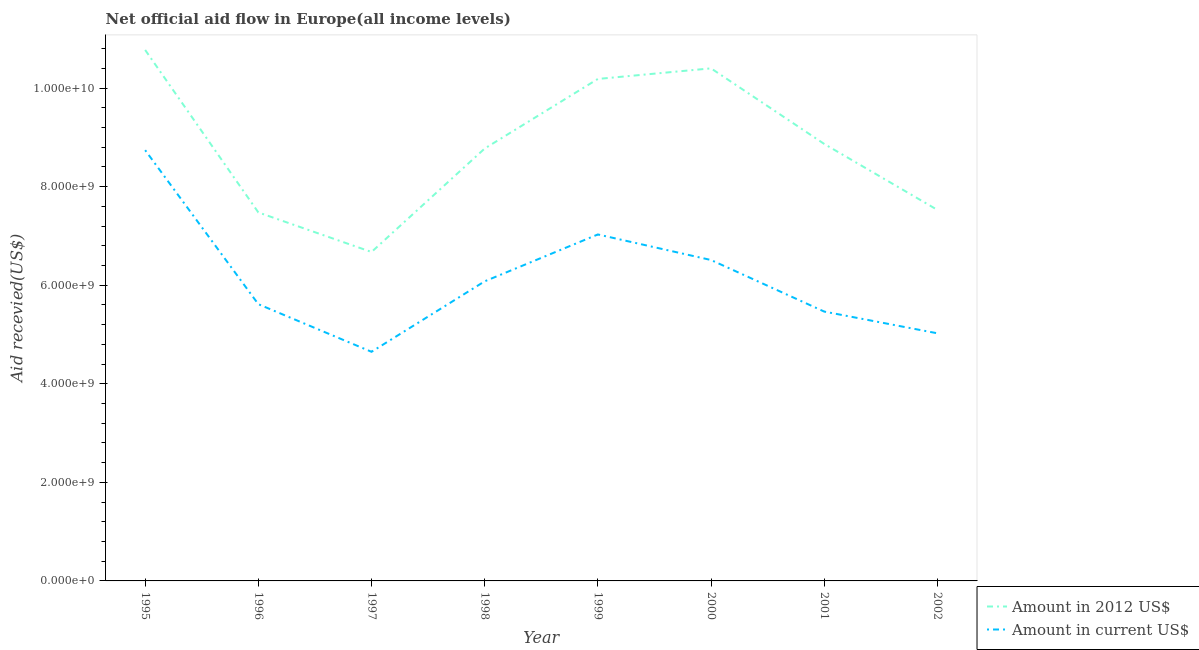How many different coloured lines are there?
Offer a very short reply. 2. Does the line corresponding to amount of aid received(expressed in 2012 us$) intersect with the line corresponding to amount of aid received(expressed in us$)?
Provide a succinct answer. No. Is the number of lines equal to the number of legend labels?
Keep it short and to the point. Yes. What is the amount of aid received(expressed in us$) in 1998?
Your answer should be compact. 6.08e+09. Across all years, what is the maximum amount of aid received(expressed in 2012 us$)?
Ensure brevity in your answer.  1.08e+1. Across all years, what is the minimum amount of aid received(expressed in us$)?
Your answer should be compact. 4.65e+09. In which year was the amount of aid received(expressed in 2012 us$) maximum?
Your answer should be compact. 1995. In which year was the amount of aid received(expressed in 2012 us$) minimum?
Your answer should be compact. 1997. What is the total amount of aid received(expressed in us$) in the graph?
Offer a very short reply. 4.91e+1. What is the difference between the amount of aid received(expressed in 2012 us$) in 1996 and that in 2000?
Provide a short and direct response. -2.92e+09. What is the difference between the amount of aid received(expressed in 2012 us$) in 1999 and the amount of aid received(expressed in us$) in 1995?
Your answer should be compact. 1.45e+09. What is the average amount of aid received(expressed in 2012 us$) per year?
Give a very brief answer. 8.84e+09. In the year 2001, what is the difference between the amount of aid received(expressed in 2012 us$) and amount of aid received(expressed in us$)?
Ensure brevity in your answer.  3.40e+09. What is the ratio of the amount of aid received(expressed in 2012 us$) in 1999 to that in 2000?
Your answer should be very brief. 0.98. Is the amount of aid received(expressed in us$) in 1997 less than that in 1999?
Ensure brevity in your answer.  Yes. What is the difference between the highest and the second highest amount of aid received(expressed in 2012 us$)?
Give a very brief answer. 3.73e+08. What is the difference between the highest and the lowest amount of aid received(expressed in 2012 us$)?
Give a very brief answer. 4.10e+09. In how many years, is the amount of aid received(expressed in 2012 us$) greater than the average amount of aid received(expressed in 2012 us$) taken over all years?
Make the answer very short. 4. Is the sum of the amount of aid received(expressed in 2012 us$) in 1995 and 2002 greater than the maximum amount of aid received(expressed in us$) across all years?
Your response must be concise. Yes. Are the values on the major ticks of Y-axis written in scientific E-notation?
Your answer should be compact. Yes. How many legend labels are there?
Your answer should be compact. 2. What is the title of the graph?
Give a very brief answer. Net official aid flow in Europe(all income levels). What is the label or title of the Y-axis?
Ensure brevity in your answer.  Aid recevied(US$). What is the Aid recevied(US$) in Amount in 2012 US$ in 1995?
Offer a very short reply. 1.08e+1. What is the Aid recevied(US$) in Amount in current US$ in 1995?
Ensure brevity in your answer.  8.74e+09. What is the Aid recevied(US$) in Amount in 2012 US$ in 1996?
Offer a terse response. 7.48e+09. What is the Aid recevied(US$) of Amount in current US$ in 1996?
Give a very brief answer. 5.62e+09. What is the Aid recevied(US$) in Amount in 2012 US$ in 1997?
Provide a succinct answer. 6.67e+09. What is the Aid recevied(US$) of Amount in current US$ in 1997?
Ensure brevity in your answer.  4.65e+09. What is the Aid recevied(US$) in Amount in 2012 US$ in 1998?
Provide a succinct answer. 8.77e+09. What is the Aid recevied(US$) of Amount in current US$ in 1998?
Keep it short and to the point. 6.08e+09. What is the Aid recevied(US$) of Amount in 2012 US$ in 1999?
Provide a short and direct response. 1.02e+1. What is the Aid recevied(US$) in Amount in current US$ in 1999?
Give a very brief answer. 7.03e+09. What is the Aid recevied(US$) in Amount in 2012 US$ in 2000?
Give a very brief answer. 1.04e+1. What is the Aid recevied(US$) of Amount in current US$ in 2000?
Offer a very short reply. 6.51e+09. What is the Aid recevied(US$) in Amount in 2012 US$ in 2001?
Make the answer very short. 8.87e+09. What is the Aid recevied(US$) of Amount in current US$ in 2001?
Give a very brief answer. 5.47e+09. What is the Aid recevied(US$) of Amount in 2012 US$ in 2002?
Ensure brevity in your answer.  7.53e+09. What is the Aid recevied(US$) of Amount in current US$ in 2002?
Your answer should be compact. 5.02e+09. Across all years, what is the maximum Aid recevied(US$) of Amount in 2012 US$?
Provide a short and direct response. 1.08e+1. Across all years, what is the maximum Aid recevied(US$) in Amount in current US$?
Your answer should be compact. 8.74e+09. Across all years, what is the minimum Aid recevied(US$) of Amount in 2012 US$?
Offer a very short reply. 6.67e+09. Across all years, what is the minimum Aid recevied(US$) of Amount in current US$?
Keep it short and to the point. 4.65e+09. What is the total Aid recevied(US$) of Amount in 2012 US$ in the graph?
Provide a short and direct response. 7.07e+1. What is the total Aid recevied(US$) of Amount in current US$ in the graph?
Give a very brief answer. 4.91e+1. What is the difference between the Aid recevied(US$) of Amount in 2012 US$ in 1995 and that in 1996?
Your answer should be compact. 3.30e+09. What is the difference between the Aid recevied(US$) in Amount in current US$ in 1995 and that in 1996?
Give a very brief answer. 3.13e+09. What is the difference between the Aid recevied(US$) in Amount in 2012 US$ in 1995 and that in 1997?
Offer a very short reply. 4.10e+09. What is the difference between the Aid recevied(US$) in Amount in current US$ in 1995 and that in 1997?
Provide a succinct answer. 4.09e+09. What is the difference between the Aid recevied(US$) in Amount in 2012 US$ in 1995 and that in 1998?
Your answer should be very brief. 2.00e+09. What is the difference between the Aid recevied(US$) of Amount in current US$ in 1995 and that in 1998?
Offer a terse response. 2.66e+09. What is the difference between the Aid recevied(US$) of Amount in 2012 US$ in 1995 and that in 1999?
Offer a terse response. 5.88e+08. What is the difference between the Aid recevied(US$) of Amount in current US$ in 1995 and that in 1999?
Provide a short and direct response. 1.71e+09. What is the difference between the Aid recevied(US$) in Amount in 2012 US$ in 1995 and that in 2000?
Your answer should be very brief. 3.73e+08. What is the difference between the Aid recevied(US$) in Amount in current US$ in 1995 and that in 2000?
Make the answer very short. 2.23e+09. What is the difference between the Aid recevied(US$) in Amount in 2012 US$ in 1995 and that in 2001?
Give a very brief answer. 1.91e+09. What is the difference between the Aid recevied(US$) in Amount in current US$ in 1995 and that in 2001?
Your response must be concise. 3.28e+09. What is the difference between the Aid recevied(US$) in Amount in 2012 US$ in 1995 and that in 2002?
Provide a succinct answer. 3.25e+09. What is the difference between the Aid recevied(US$) of Amount in current US$ in 1995 and that in 2002?
Provide a short and direct response. 3.72e+09. What is the difference between the Aid recevied(US$) of Amount in 2012 US$ in 1996 and that in 1997?
Provide a short and direct response. 8.03e+08. What is the difference between the Aid recevied(US$) in Amount in current US$ in 1996 and that in 1997?
Give a very brief answer. 9.66e+08. What is the difference between the Aid recevied(US$) of Amount in 2012 US$ in 1996 and that in 1998?
Provide a short and direct response. -1.30e+09. What is the difference between the Aid recevied(US$) of Amount in current US$ in 1996 and that in 1998?
Provide a succinct answer. -4.64e+08. What is the difference between the Aid recevied(US$) of Amount in 2012 US$ in 1996 and that in 1999?
Provide a succinct answer. -2.71e+09. What is the difference between the Aid recevied(US$) in Amount in current US$ in 1996 and that in 1999?
Your answer should be very brief. -1.41e+09. What is the difference between the Aid recevied(US$) of Amount in 2012 US$ in 1996 and that in 2000?
Give a very brief answer. -2.92e+09. What is the difference between the Aid recevied(US$) of Amount in current US$ in 1996 and that in 2000?
Offer a terse response. -8.96e+08. What is the difference between the Aid recevied(US$) in Amount in 2012 US$ in 1996 and that in 2001?
Your response must be concise. -1.39e+09. What is the difference between the Aid recevied(US$) in Amount in current US$ in 1996 and that in 2001?
Give a very brief answer. 1.50e+08. What is the difference between the Aid recevied(US$) in Amount in 2012 US$ in 1996 and that in 2002?
Your response must be concise. -5.12e+07. What is the difference between the Aid recevied(US$) of Amount in current US$ in 1996 and that in 2002?
Provide a short and direct response. 5.91e+08. What is the difference between the Aid recevied(US$) in Amount in 2012 US$ in 1997 and that in 1998?
Offer a very short reply. -2.10e+09. What is the difference between the Aid recevied(US$) of Amount in current US$ in 1997 and that in 1998?
Your answer should be compact. -1.43e+09. What is the difference between the Aid recevied(US$) in Amount in 2012 US$ in 1997 and that in 1999?
Your response must be concise. -3.51e+09. What is the difference between the Aid recevied(US$) in Amount in current US$ in 1997 and that in 1999?
Provide a succinct answer. -2.38e+09. What is the difference between the Aid recevied(US$) in Amount in 2012 US$ in 1997 and that in 2000?
Give a very brief answer. -3.73e+09. What is the difference between the Aid recevied(US$) in Amount in current US$ in 1997 and that in 2000?
Your answer should be very brief. -1.86e+09. What is the difference between the Aid recevied(US$) of Amount in 2012 US$ in 1997 and that in 2001?
Your answer should be very brief. -2.19e+09. What is the difference between the Aid recevied(US$) in Amount in current US$ in 1997 and that in 2001?
Your answer should be very brief. -8.16e+08. What is the difference between the Aid recevied(US$) of Amount in 2012 US$ in 1997 and that in 2002?
Provide a short and direct response. -8.54e+08. What is the difference between the Aid recevied(US$) of Amount in current US$ in 1997 and that in 2002?
Your answer should be compact. -3.75e+08. What is the difference between the Aid recevied(US$) of Amount in 2012 US$ in 1998 and that in 1999?
Your response must be concise. -1.41e+09. What is the difference between the Aid recevied(US$) in Amount in current US$ in 1998 and that in 1999?
Keep it short and to the point. -9.51e+08. What is the difference between the Aid recevied(US$) in Amount in 2012 US$ in 1998 and that in 2000?
Keep it short and to the point. -1.63e+09. What is the difference between the Aid recevied(US$) in Amount in current US$ in 1998 and that in 2000?
Ensure brevity in your answer.  -4.32e+08. What is the difference between the Aid recevied(US$) of Amount in 2012 US$ in 1998 and that in 2001?
Give a very brief answer. -9.31e+07. What is the difference between the Aid recevied(US$) in Amount in current US$ in 1998 and that in 2001?
Provide a short and direct response. 6.14e+08. What is the difference between the Aid recevied(US$) in Amount in 2012 US$ in 1998 and that in 2002?
Keep it short and to the point. 1.25e+09. What is the difference between the Aid recevied(US$) of Amount in current US$ in 1998 and that in 2002?
Your answer should be very brief. 1.05e+09. What is the difference between the Aid recevied(US$) of Amount in 2012 US$ in 1999 and that in 2000?
Make the answer very short. -2.15e+08. What is the difference between the Aid recevied(US$) of Amount in current US$ in 1999 and that in 2000?
Your answer should be very brief. 5.19e+08. What is the difference between the Aid recevied(US$) of Amount in 2012 US$ in 1999 and that in 2001?
Your response must be concise. 1.32e+09. What is the difference between the Aid recevied(US$) of Amount in current US$ in 1999 and that in 2001?
Give a very brief answer. 1.57e+09. What is the difference between the Aid recevied(US$) of Amount in 2012 US$ in 1999 and that in 2002?
Give a very brief answer. 2.66e+09. What is the difference between the Aid recevied(US$) of Amount in current US$ in 1999 and that in 2002?
Make the answer very short. 2.01e+09. What is the difference between the Aid recevied(US$) in Amount in 2012 US$ in 2000 and that in 2001?
Your response must be concise. 1.53e+09. What is the difference between the Aid recevied(US$) in Amount in current US$ in 2000 and that in 2001?
Your answer should be compact. 1.05e+09. What is the difference between the Aid recevied(US$) in Amount in 2012 US$ in 2000 and that in 2002?
Offer a very short reply. 2.87e+09. What is the difference between the Aid recevied(US$) of Amount in current US$ in 2000 and that in 2002?
Offer a very short reply. 1.49e+09. What is the difference between the Aid recevied(US$) in Amount in 2012 US$ in 2001 and that in 2002?
Ensure brevity in your answer.  1.34e+09. What is the difference between the Aid recevied(US$) in Amount in current US$ in 2001 and that in 2002?
Give a very brief answer. 4.41e+08. What is the difference between the Aid recevied(US$) in Amount in 2012 US$ in 1995 and the Aid recevied(US$) in Amount in current US$ in 1996?
Offer a terse response. 5.16e+09. What is the difference between the Aid recevied(US$) in Amount in 2012 US$ in 1995 and the Aid recevied(US$) in Amount in current US$ in 1997?
Your answer should be compact. 6.12e+09. What is the difference between the Aid recevied(US$) of Amount in 2012 US$ in 1995 and the Aid recevied(US$) of Amount in current US$ in 1998?
Offer a terse response. 4.69e+09. What is the difference between the Aid recevied(US$) in Amount in 2012 US$ in 1995 and the Aid recevied(US$) in Amount in current US$ in 1999?
Your answer should be compact. 3.74e+09. What is the difference between the Aid recevied(US$) of Amount in 2012 US$ in 1995 and the Aid recevied(US$) of Amount in current US$ in 2000?
Offer a very short reply. 4.26e+09. What is the difference between the Aid recevied(US$) of Amount in 2012 US$ in 1995 and the Aid recevied(US$) of Amount in current US$ in 2001?
Your answer should be very brief. 5.31e+09. What is the difference between the Aid recevied(US$) in Amount in 2012 US$ in 1995 and the Aid recevied(US$) in Amount in current US$ in 2002?
Keep it short and to the point. 5.75e+09. What is the difference between the Aid recevied(US$) of Amount in 2012 US$ in 1996 and the Aid recevied(US$) of Amount in current US$ in 1997?
Provide a short and direct response. 2.83e+09. What is the difference between the Aid recevied(US$) in Amount in 2012 US$ in 1996 and the Aid recevied(US$) in Amount in current US$ in 1998?
Your response must be concise. 1.40e+09. What is the difference between the Aid recevied(US$) of Amount in 2012 US$ in 1996 and the Aid recevied(US$) of Amount in current US$ in 1999?
Your answer should be very brief. 4.47e+08. What is the difference between the Aid recevied(US$) of Amount in 2012 US$ in 1996 and the Aid recevied(US$) of Amount in current US$ in 2000?
Make the answer very short. 9.66e+08. What is the difference between the Aid recevied(US$) in Amount in 2012 US$ in 1996 and the Aid recevied(US$) in Amount in current US$ in 2001?
Your response must be concise. 2.01e+09. What is the difference between the Aid recevied(US$) in Amount in 2012 US$ in 1996 and the Aid recevied(US$) in Amount in current US$ in 2002?
Give a very brief answer. 2.45e+09. What is the difference between the Aid recevied(US$) of Amount in 2012 US$ in 1997 and the Aid recevied(US$) of Amount in current US$ in 1998?
Offer a very short reply. 5.95e+08. What is the difference between the Aid recevied(US$) in Amount in 2012 US$ in 1997 and the Aid recevied(US$) in Amount in current US$ in 1999?
Your response must be concise. -3.56e+08. What is the difference between the Aid recevied(US$) in Amount in 2012 US$ in 1997 and the Aid recevied(US$) in Amount in current US$ in 2000?
Ensure brevity in your answer.  1.63e+08. What is the difference between the Aid recevied(US$) in Amount in 2012 US$ in 1997 and the Aid recevied(US$) in Amount in current US$ in 2001?
Keep it short and to the point. 1.21e+09. What is the difference between the Aid recevied(US$) in Amount in 2012 US$ in 1997 and the Aid recevied(US$) in Amount in current US$ in 2002?
Your answer should be compact. 1.65e+09. What is the difference between the Aid recevied(US$) of Amount in 2012 US$ in 1998 and the Aid recevied(US$) of Amount in current US$ in 1999?
Provide a succinct answer. 1.74e+09. What is the difference between the Aid recevied(US$) of Amount in 2012 US$ in 1998 and the Aid recevied(US$) of Amount in current US$ in 2000?
Keep it short and to the point. 2.26e+09. What is the difference between the Aid recevied(US$) in Amount in 2012 US$ in 1998 and the Aid recevied(US$) in Amount in current US$ in 2001?
Your response must be concise. 3.31e+09. What is the difference between the Aid recevied(US$) in Amount in 2012 US$ in 1998 and the Aid recevied(US$) in Amount in current US$ in 2002?
Give a very brief answer. 3.75e+09. What is the difference between the Aid recevied(US$) of Amount in 2012 US$ in 1999 and the Aid recevied(US$) of Amount in current US$ in 2000?
Keep it short and to the point. 3.67e+09. What is the difference between the Aid recevied(US$) in Amount in 2012 US$ in 1999 and the Aid recevied(US$) in Amount in current US$ in 2001?
Provide a short and direct response. 4.72e+09. What is the difference between the Aid recevied(US$) of Amount in 2012 US$ in 1999 and the Aid recevied(US$) of Amount in current US$ in 2002?
Ensure brevity in your answer.  5.16e+09. What is the difference between the Aid recevied(US$) of Amount in 2012 US$ in 2000 and the Aid recevied(US$) of Amount in current US$ in 2001?
Make the answer very short. 4.94e+09. What is the difference between the Aid recevied(US$) in Amount in 2012 US$ in 2000 and the Aid recevied(US$) in Amount in current US$ in 2002?
Your answer should be very brief. 5.38e+09. What is the difference between the Aid recevied(US$) in Amount in 2012 US$ in 2001 and the Aid recevied(US$) in Amount in current US$ in 2002?
Give a very brief answer. 3.84e+09. What is the average Aid recevied(US$) in Amount in 2012 US$ per year?
Provide a short and direct response. 8.84e+09. What is the average Aid recevied(US$) of Amount in current US$ per year?
Keep it short and to the point. 6.14e+09. In the year 1995, what is the difference between the Aid recevied(US$) in Amount in 2012 US$ and Aid recevied(US$) in Amount in current US$?
Offer a terse response. 2.03e+09. In the year 1996, what is the difference between the Aid recevied(US$) of Amount in 2012 US$ and Aid recevied(US$) of Amount in current US$?
Make the answer very short. 1.86e+09. In the year 1997, what is the difference between the Aid recevied(US$) of Amount in 2012 US$ and Aid recevied(US$) of Amount in current US$?
Keep it short and to the point. 2.03e+09. In the year 1998, what is the difference between the Aid recevied(US$) in Amount in 2012 US$ and Aid recevied(US$) in Amount in current US$?
Provide a succinct answer. 2.69e+09. In the year 1999, what is the difference between the Aid recevied(US$) in Amount in 2012 US$ and Aid recevied(US$) in Amount in current US$?
Give a very brief answer. 3.16e+09. In the year 2000, what is the difference between the Aid recevied(US$) of Amount in 2012 US$ and Aid recevied(US$) of Amount in current US$?
Your answer should be compact. 3.89e+09. In the year 2001, what is the difference between the Aid recevied(US$) of Amount in 2012 US$ and Aid recevied(US$) of Amount in current US$?
Offer a very short reply. 3.40e+09. In the year 2002, what is the difference between the Aid recevied(US$) in Amount in 2012 US$ and Aid recevied(US$) in Amount in current US$?
Offer a terse response. 2.50e+09. What is the ratio of the Aid recevied(US$) in Amount in 2012 US$ in 1995 to that in 1996?
Provide a short and direct response. 1.44. What is the ratio of the Aid recevied(US$) of Amount in current US$ in 1995 to that in 1996?
Give a very brief answer. 1.56. What is the ratio of the Aid recevied(US$) in Amount in 2012 US$ in 1995 to that in 1997?
Keep it short and to the point. 1.61. What is the ratio of the Aid recevied(US$) of Amount in current US$ in 1995 to that in 1997?
Offer a very short reply. 1.88. What is the ratio of the Aid recevied(US$) in Amount in 2012 US$ in 1995 to that in 1998?
Give a very brief answer. 1.23. What is the ratio of the Aid recevied(US$) of Amount in current US$ in 1995 to that in 1998?
Ensure brevity in your answer.  1.44. What is the ratio of the Aid recevied(US$) in Amount in 2012 US$ in 1995 to that in 1999?
Your answer should be very brief. 1.06. What is the ratio of the Aid recevied(US$) of Amount in current US$ in 1995 to that in 1999?
Your answer should be compact. 1.24. What is the ratio of the Aid recevied(US$) in Amount in 2012 US$ in 1995 to that in 2000?
Your answer should be very brief. 1.04. What is the ratio of the Aid recevied(US$) of Amount in current US$ in 1995 to that in 2000?
Make the answer very short. 1.34. What is the ratio of the Aid recevied(US$) of Amount in 2012 US$ in 1995 to that in 2001?
Your response must be concise. 1.22. What is the ratio of the Aid recevied(US$) in Amount in current US$ in 1995 to that in 2001?
Keep it short and to the point. 1.6. What is the ratio of the Aid recevied(US$) of Amount in 2012 US$ in 1995 to that in 2002?
Make the answer very short. 1.43. What is the ratio of the Aid recevied(US$) in Amount in current US$ in 1995 to that in 2002?
Your answer should be compact. 1.74. What is the ratio of the Aid recevied(US$) in Amount in 2012 US$ in 1996 to that in 1997?
Offer a very short reply. 1.12. What is the ratio of the Aid recevied(US$) of Amount in current US$ in 1996 to that in 1997?
Give a very brief answer. 1.21. What is the ratio of the Aid recevied(US$) in Amount in 2012 US$ in 1996 to that in 1998?
Your response must be concise. 0.85. What is the ratio of the Aid recevied(US$) of Amount in current US$ in 1996 to that in 1998?
Your answer should be compact. 0.92. What is the ratio of the Aid recevied(US$) in Amount in 2012 US$ in 1996 to that in 1999?
Make the answer very short. 0.73. What is the ratio of the Aid recevied(US$) in Amount in current US$ in 1996 to that in 1999?
Give a very brief answer. 0.8. What is the ratio of the Aid recevied(US$) in Amount in 2012 US$ in 1996 to that in 2000?
Your answer should be compact. 0.72. What is the ratio of the Aid recevied(US$) in Amount in current US$ in 1996 to that in 2000?
Your answer should be compact. 0.86. What is the ratio of the Aid recevied(US$) of Amount in 2012 US$ in 1996 to that in 2001?
Offer a terse response. 0.84. What is the ratio of the Aid recevied(US$) in Amount in current US$ in 1996 to that in 2001?
Your answer should be compact. 1.03. What is the ratio of the Aid recevied(US$) of Amount in 2012 US$ in 1996 to that in 2002?
Keep it short and to the point. 0.99. What is the ratio of the Aid recevied(US$) of Amount in current US$ in 1996 to that in 2002?
Make the answer very short. 1.12. What is the ratio of the Aid recevied(US$) in Amount in 2012 US$ in 1997 to that in 1998?
Make the answer very short. 0.76. What is the ratio of the Aid recevied(US$) of Amount in current US$ in 1997 to that in 1998?
Offer a very short reply. 0.76. What is the ratio of the Aid recevied(US$) in Amount in 2012 US$ in 1997 to that in 1999?
Give a very brief answer. 0.66. What is the ratio of the Aid recevied(US$) of Amount in current US$ in 1997 to that in 1999?
Provide a short and direct response. 0.66. What is the ratio of the Aid recevied(US$) in Amount in 2012 US$ in 1997 to that in 2000?
Offer a terse response. 0.64. What is the ratio of the Aid recevied(US$) in Amount in current US$ in 1997 to that in 2000?
Provide a short and direct response. 0.71. What is the ratio of the Aid recevied(US$) of Amount in 2012 US$ in 1997 to that in 2001?
Give a very brief answer. 0.75. What is the ratio of the Aid recevied(US$) of Amount in current US$ in 1997 to that in 2001?
Offer a terse response. 0.85. What is the ratio of the Aid recevied(US$) in Amount in 2012 US$ in 1997 to that in 2002?
Provide a succinct answer. 0.89. What is the ratio of the Aid recevied(US$) of Amount in current US$ in 1997 to that in 2002?
Give a very brief answer. 0.93. What is the ratio of the Aid recevied(US$) in Amount in 2012 US$ in 1998 to that in 1999?
Provide a short and direct response. 0.86. What is the ratio of the Aid recevied(US$) in Amount in current US$ in 1998 to that in 1999?
Ensure brevity in your answer.  0.86. What is the ratio of the Aid recevied(US$) of Amount in 2012 US$ in 1998 to that in 2000?
Give a very brief answer. 0.84. What is the ratio of the Aid recevied(US$) of Amount in current US$ in 1998 to that in 2000?
Give a very brief answer. 0.93. What is the ratio of the Aid recevied(US$) in Amount in current US$ in 1998 to that in 2001?
Make the answer very short. 1.11. What is the ratio of the Aid recevied(US$) in Amount in 2012 US$ in 1998 to that in 2002?
Give a very brief answer. 1.17. What is the ratio of the Aid recevied(US$) of Amount in current US$ in 1998 to that in 2002?
Your answer should be compact. 1.21. What is the ratio of the Aid recevied(US$) of Amount in 2012 US$ in 1999 to that in 2000?
Provide a succinct answer. 0.98. What is the ratio of the Aid recevied(US$) of Amount in current US$ in 1999 to that in 2000?
Your answer should be compact. 1.08. What is the ratio of the Aid recevied(US$) of Amount in 2012 US$ in 1999 to that in 2001?
Keep it short and to the point. 1.15. What is the ratio of the Aid recevied(US$) of Amount in current US$ in 1999 to that in 2001?
Make the answer very short. 1.29. What is the ratio of the Aid recevied(US$) of Amount in 2012 US$ in 1999 to that in 2002?
Your answer should be compact. 1.35. What is the ratio of the Aid recevied(US$) of Amount in current US$ in 1999 to that in 2002?
Ensure brevity in your answer.  1.4. What is the ratio of the Aid recevied(US$) in Amount in 2012 US$ in 2000 to that in 2001?
Your answer should be very brief. 1.17. What is the ratio of the Aid recevied(US$) of Amount in current US$ in 2000 to that in 2001?
Your answer should be very brief. 1.19. What is the ratio of the Aid recevied(US$) of Amount in 2012 US$ in 2000 to that in 2002?
Provide a succinct answer. 1.38. What is the ratio of the Aid recevied(US$) of Amount in current US$ in 2000 to that in 2002?
Your answer should be very brief. 1.3. What is the ratio of the Aid recevied(US$) of Amount in 2012 US$ in 2001 to that in 2002?
Provide a short and direct response. 1.18. What is the ratio of the Aid recevied(US$) of Amount in current US$ in 2001 to that in 2002?
Provide a short and direct response. 1.09. What is the difference between the highest and the second highest Aid recevied(US$) in Amount in 2012 US$?
Make the answer very short. 3.73e+08. What is the difference between the highest and the second highest Aid recevied(US$) in Amount in current US$?
Offer a very short reply. 1.71e+09. What is the difference between the highest and the lowest Aid recevied(US$) in Amount in 2012 US$?
Give a very brief answer. 4.10e+09. What is the difference between the highest and the lowest Aid recevied(US$) of Amount in current US$?
Keep it short and to the point. 4.09e+09. 